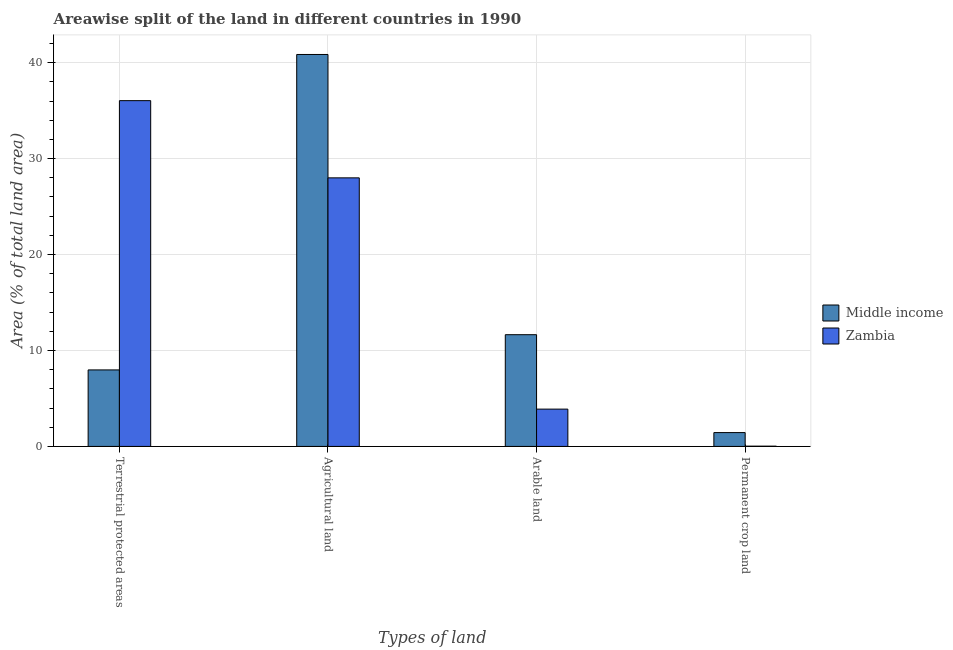How many groups of bars are there?
Your response must be concise. 4. Are the number of bars on each tick of the X-axis equal?
Provide a succinct answer. Yes. How many bars are there on the 3rd tick from the left?
Keep it short and to the point. 2. What is the label of the 1st group of bars from the left?
Provide a succinct answer. Terrestrial protected areas. What is the percentage of area under permanent crop land in Middle income?
Your answer should be compact. 1.44. Across all countries, what is the maximum percentage of area under arable land?
Make the answer very short. 11.65. Across all countries, what is the minimum percentage of area under permanent crop land?
Keep it short and to the point. 0.03. In which country was the percentage of area under arable land maximum?
Keep it short and to the point. Middle income. In which country was the percentage of area under agricultural land minimum?
Ensure brevity in your answer.  Zambia. What is the total percentage of area under permanent crop land in the graph?
Provide a succinct answer. 1.47. What is the difference between the percentage of area under arable land in Middle income and that in Zambia?
Give a very brief answer. 7.76. What is the difference between the percentage of area under permanent crop land in Zambia and the percentage of land under terrestrial protection in Middle income?
Your response must be concise. -7.95. What is the average percentage of area under arable land per country?
Your answer should be compact. 7.77. What is the difference between the percentage of area under arable land and percentage of area under agricultural land in Zambia?
Offer a terse response. -24.11. What is the ratio of the percentage of area under arable land in Zambia to that in Middle income?
Provide a succinct answer. 0.33. Is the difference between the percentage of land under terrestrial protection in Zambia and Middle income greater than the difference between the percentage of area under permanent crop land in Zambia and Middle income?
Your answer should be very brief. Yes. What is the difference between the highest and the second highest percentage of area under arable land?
Provide a short and direct response. 7.76. What is the difference between the highest and the lowest percentage of area under agricultural land?
Provide a succinct answer. 12.86. Is the sum of the percentage of area under agricultural land in Zambia and Middle income greater than the maximum percentage of area under arable land across all countries?
Give a very brief answer. Yes. What does the 2nd bar from the left in Permanent crop land represents?
Provide a short and direct response. Zambia. What does the 1st bar from the right in Terrestrial protected areas represents?
Your answer should be very brief. Zambia. Is it the case that in every country, the sum of the percentage of land under terrestrial protection and percentage of area under agricultural land is greater than the percentage of area under arable land?
Keep it short and to the point. Yes. Are all the bars in the graph horizontal?
Your answer should be very brief. No. What is the difference between two consecutive major ticks on the Y-axis?
Offer a very short reply. 10. Are the values on the major ticks of Y-axis written in scientific E-notation?
Offer a terse response. No. Does the graph contain any zero values?
Your answer should be very brief. No. Where does the legend appear in the graph?
Provide a short and direct response. Center right. How are the legend labels stacked?
Your answer should be very brief. Vertical. What is the title of the graph?
Provide a succinct answer. Areawise split of the land in different countries in 1990. What is the label or title of the X-axis?
Give a very brief answer. Types of land. What is the label or title of the Y-axis?
Give a very brief answer. Area (% of total land area). What is the Area (% of total land area) of Middle income in Terrestrial protected areas?
Give a very brief answer. 7.98. What is the Area (% of total land area) of Zambia in Terrestrial protected areas?
Provide a short and direct response. 36.04. What is the Area (% of total land area) in Middle income in Agricultural land?
Offer a very short reply. 40.86. What is the Area (% of total land area) of Zambia in Agricultural land?
Keep it short and to the point. 27.99. What is the Area (% of total land area) in Middle income in Arable land?
Give a very brief answer. 11.65. What is the Area (% of total land area) in Zambia in Arable land?
Your answer should be compact. 3.89. What is the Area (% of total land area) in Middle income in Permanent crop land?
Keep it short and to the point. 1.44. What is the Area (% of total land area) of Zambia in Permanent crop land?
Offer a terse response. 0.03. Across all Types of land, what is the maximum Area (% of total land area) in Middle income?
Give a very brief answer. 40.86. Across all Types of land, what is the maximum Area (% of total land area) in Zambia?
Give a very brief answer. 36.04. Across all Types of land, what is the minimum Area (% of total land area) in Middle income?
Your response must be concise. 1.44. Across all Types of land, what is the minimum Area (% of total land area) of Zambia?
Your answer should be very brief. 0.03. What is the total Area (% of total land area) in Middle income in the graph?
Make the answer very short. 61.92. What is the total Area (% of total land area) in Zambia in the graph?
Keep it short and to the point. 67.95. What is the difference between the Area (% of total land area) of Middle income in Terrestrial protected areas and that in Agricultural land?
Ensure brevity in your answer.  -32.88. What is the difference between the Area (% of total land area) of Zambia in Terrestrial protected areas and that in Agricultural land?
Give a very brief answer. 8.05. What is the difference between the Area (% of total land area) of Middle income in Terrestrial protected areas and that in Arable land?
Offer a very short reply. -3.67. What is the difference between the Area (% of total land area) of Zambia in Terrestrial protected areas and that in Arable land?
Offer a terse response. 32.15. What is the difference between the Area (% of total land area) in Middle income in Terrestrial protected areas and that in Permanent crop land?
Your response must be concise. 6.53. What is the difference between the Area (% of total land area) in Zambia in Terrestrial protected areas and that in Permanent crop land?
Make the answer very short. 36.02. What is the difference between the Area (% of total land area) of Middle income in Agricultural land and that in Arable land?
Your answer should be very brief. 29.21. What is the difference between the Area (% of total land area) in Zambia in Agricultural land and that in Arable land?
Offer a very short reply. 24.11. What is the difference between the Area (% of total land area) of Middle income in Agricultural land and that in Permanent crop land?
Offer a very short reply. 39.41. What is the difference between the Area (% of total land area) of Zambia in Agricultural land and that in Permanent crop land?
Offer a very short reply. 27.97. What is the difference between the Area (% of total land area) in Middle income in Arable land and that in Permanent crop land?
Ensure brevity in your answer.  10.2. What is the difference between the Area (% of total land area) in Zambia in Arable land and that in Permanent crop land?
Your answer should be compact. 3.86. What is the difference between the Area (% of total land area) of Middle income in Terrestrial protected areas and the Area (% of total land area) of Zambia in Agricultural land?
Keep it short and to the point. -20.02. What is the difference between the Area (% of total land area) of Middle income in Terrestrial protected areas and the Area (% of total land area) of Zambia in Arable land?
Ensure brevity in your answer.  4.09. What is the difference between the Area (% of total land area) in Middle income in Terrestrial protected areas and the Area (% of total land area) in Zambia in Permanent crop land?
Provide a succinct answer. 7.95. What is the difference between the Area (% of total land area) of Middle income in Agricultural land and the Area (% of total land area) of Zambia in Arable land?
Your answer should be compact. 36.97. What is the difference between the Area (% of total land area) in Middle income in Agricultural land and the Area (% of total land area) in Zambia in Permanent crop land?
Make the answer very short. 40.83. What is the difference between the Area (% of total land area) of Middle income in Arable land and the Area (% of total land area) of Zambia in Permanent crop land?
Offer a terse response. 11.62. What is the average Area (% of total land area) of Middle income per Types of land?
Your response must be concise. 15.48. What is the average Area (% of total land area) in Zambia per Types of land?
Offer a very short reply. 16.99. What is the difference between the Area (% of total land area) in Middle income and Area (% of total land area) in Zambia in Terrestrial protected areas?
Your response must be concise. -28.07. What is the difference between the Area (% of total land area) in Middle income and Area (% of total land area) in Zambia in Agricultural land?
Offer a terse response. 12.86. What is the difference between the Area (% of total land area) in Middle income and Area (% of total land area) in Zambia in Arable land?
Offer a very short reply. 7.76. What is the difference between the Area (% of total land area) of Middle income and Area (% of total land area) of Zambia in Permanent crop land?
Provide a short and direct response. 1.42. What is the ratio of the Area (% of total land area) in Middle income in Terrestrial protected areas to that in Agricultural land?
Offer a very short reply. 0.2. What is the ratio of the Area (% of total land area) in Zambia in Terrestrial protected areas to that in Agricultural land?
Offer a terse response. 1.29. What is the ratio of the Area (% of total land area) of Middle income in Terrestrial protected areas to that in Arable land?
Make the answer very short. 0.68. What is the ratio of the Area (% of total land area) of Zambia in Terrestrial protected areas to that in Arable land?
Offer a terse response. 9.27. What is the ratio of the Area (% of total land area) of Middle income in Terrestrial protected areas to that in Permanent crop land?
Provide a short and direct response. 5.53. What is the ratio of the Area (% of total land area) in Zambia in Terrestrial protected areas to that in Permanent crop land?
Your answer should be very brief. 1339.68. What is the ratio of the Area (% of total land area) of Middle income in Agricultural land to that in Arable land?
Make the answer very short. 3.51. What is the ratio of the Area (% of total land area) of Zambia in Agricultural land to that in Arable land?
Offer a terse response. 7.2. What is the ratio of the Area (% of total land area) of Middle income in Agricultural land to that in Permanent crop land?
Provide a short and direct response. 28.31. What is the ratio of the Area (% of total land area) in Zambia in Agricultural land to that in Permanent crop land?
Ensure brevity in your answer.  1040.55. What is the ratio of the Area (% of total land area) in Middle income in Arable land to that in Permanent crop land?
Keep it short and to the point. 8.07. What is the ratio of the Area (% of total land area) in Zambia in Arable land to that in Permanent crop land?
Make the answer very short. 144.55. What is the difference between the highest and the second highest Area (% of total land area) of Middle income?
Offer a very short reply. 29.21. What is the difference between the highest and the second highest Area (% of total land area) of Zambia?
Ensure brevity in your answer.  8.05. What is the difference between the highest and the lowest Area (% of total land area) of Middle income?
Give a very brief answer. 39.41. What is the difference between the highest and the lowest Area (% of total land area) of Zambia?
Make the answer very short. 36.02. 